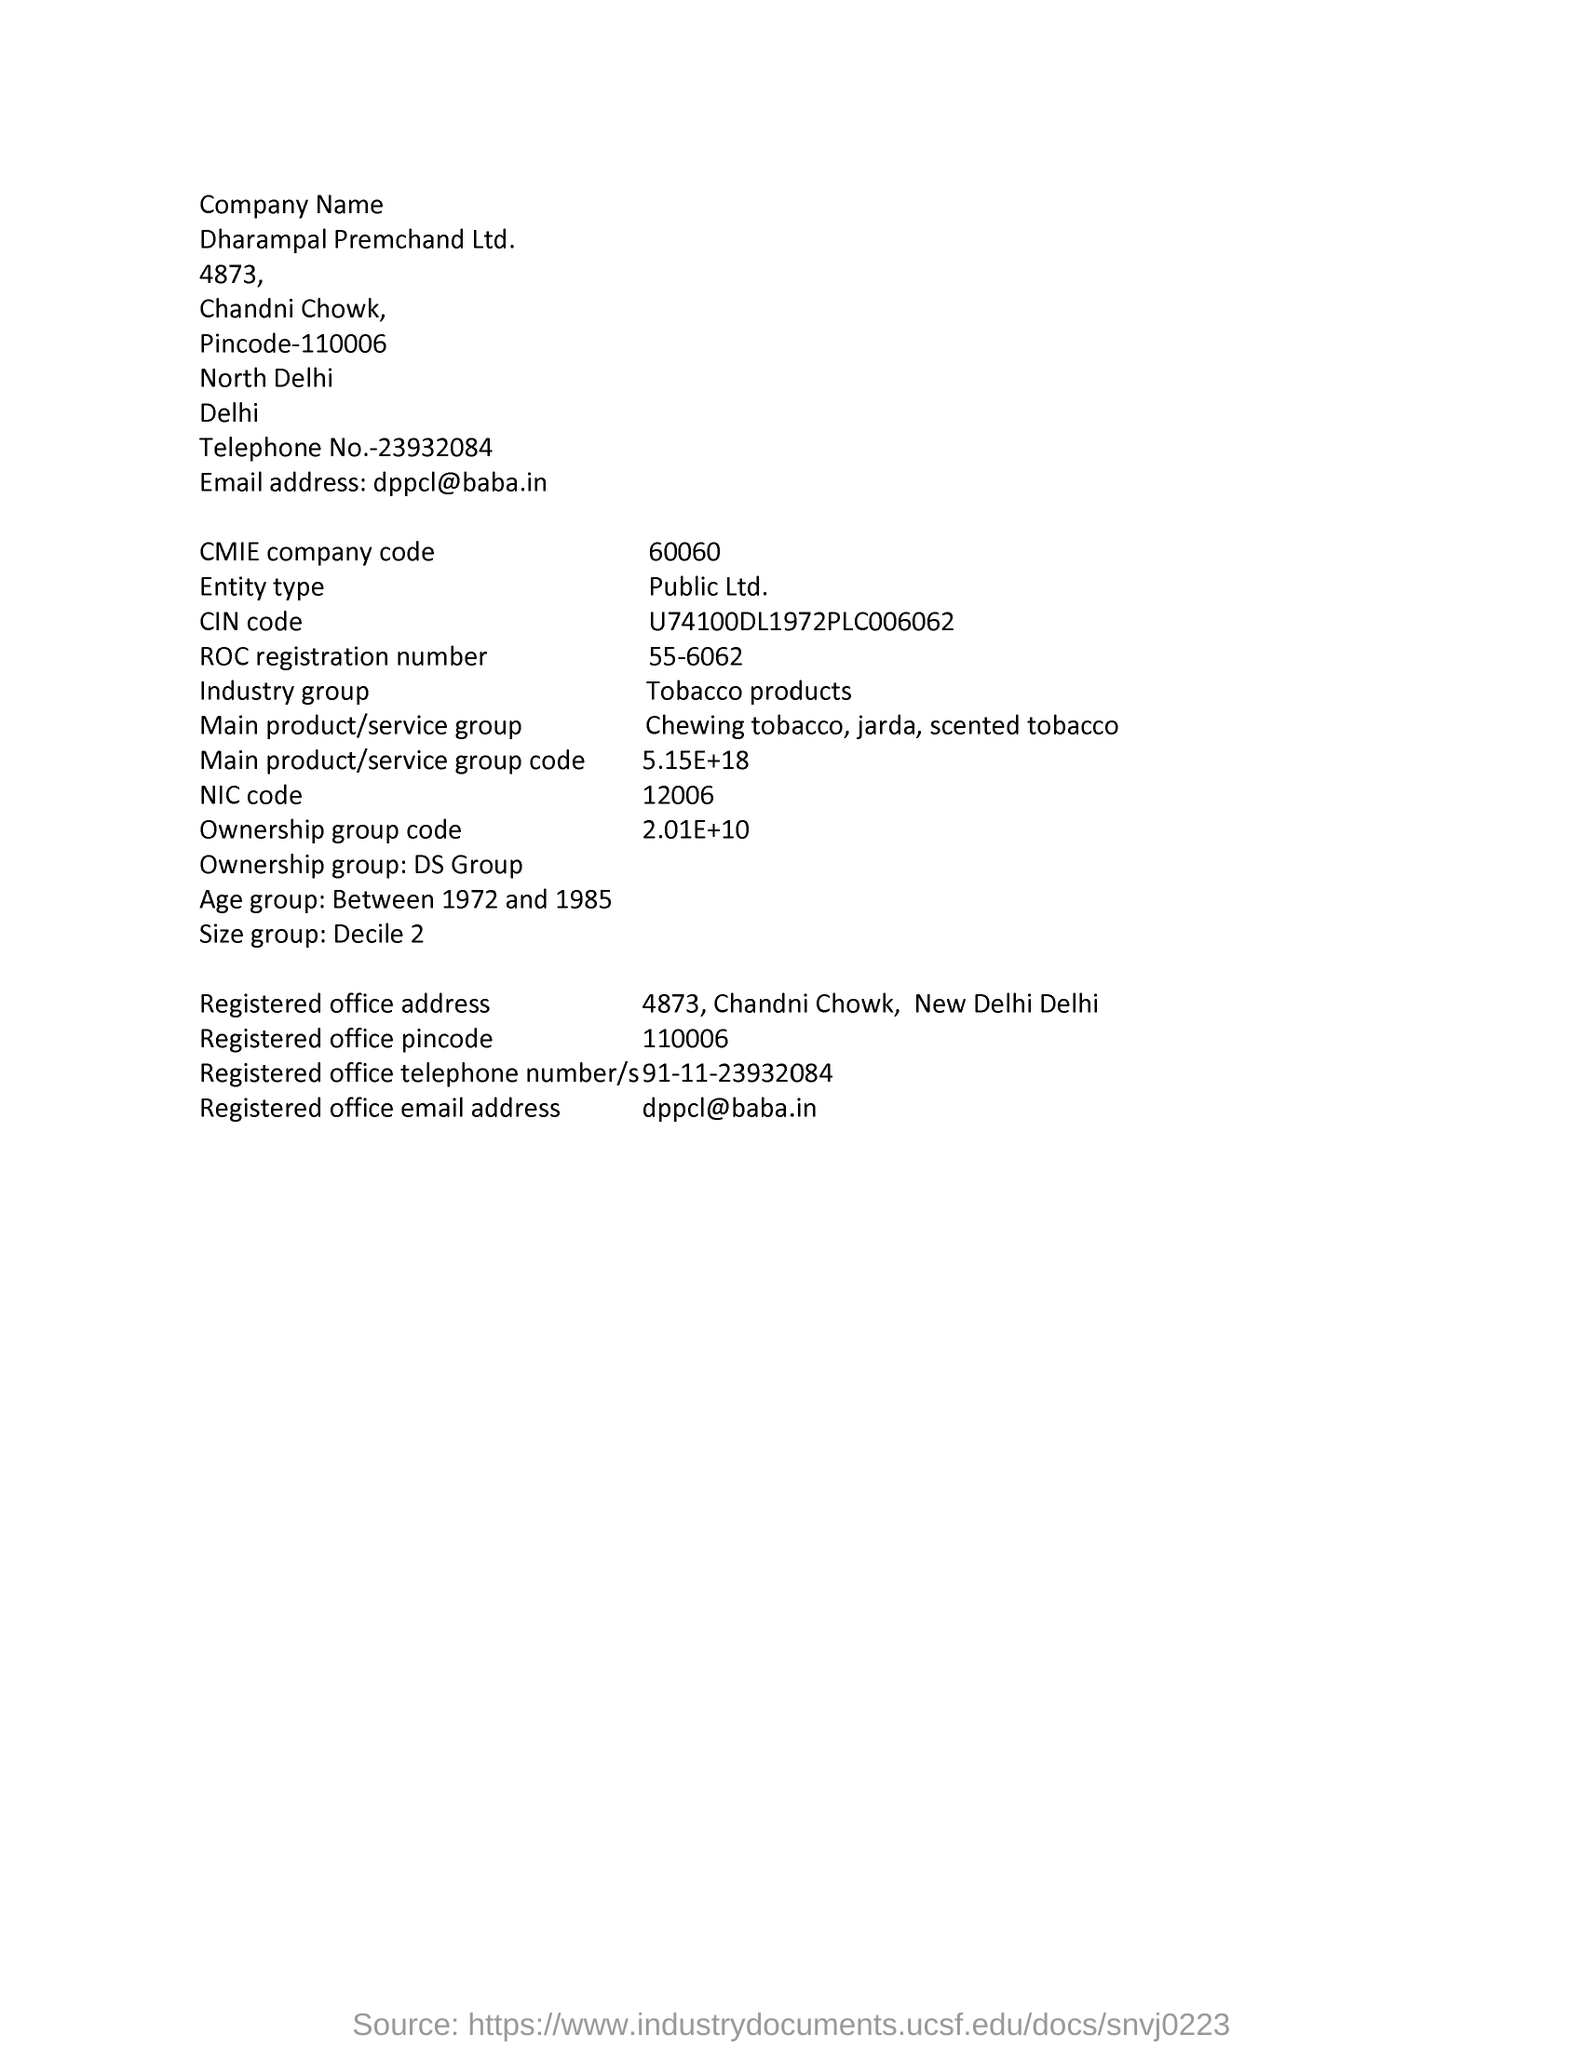What is the company name mentioned in this document?
Your answer should be very brief. Dharampal Premchand Ltd. What is the CMIE company code given in the document?
Offer a very short reply. 60060. What is the Entity type mentioned in the document?
Provide a short and direct response. Public Ltd. What is the ROC registration number given in the document?
Make the answer very short. 55-6062. What is the Industry Group as per the document?
Keep it short and to the point. Tobacco products. What is the NIC Code given in the document?
Give a very brief answer. 12006. Which Age group is mentioned in this document?
Provide a short and direct response. Between 1972 and 1985. What is the Ownership group code given in the document?
Offer a very short reply. 2.01E+10. 